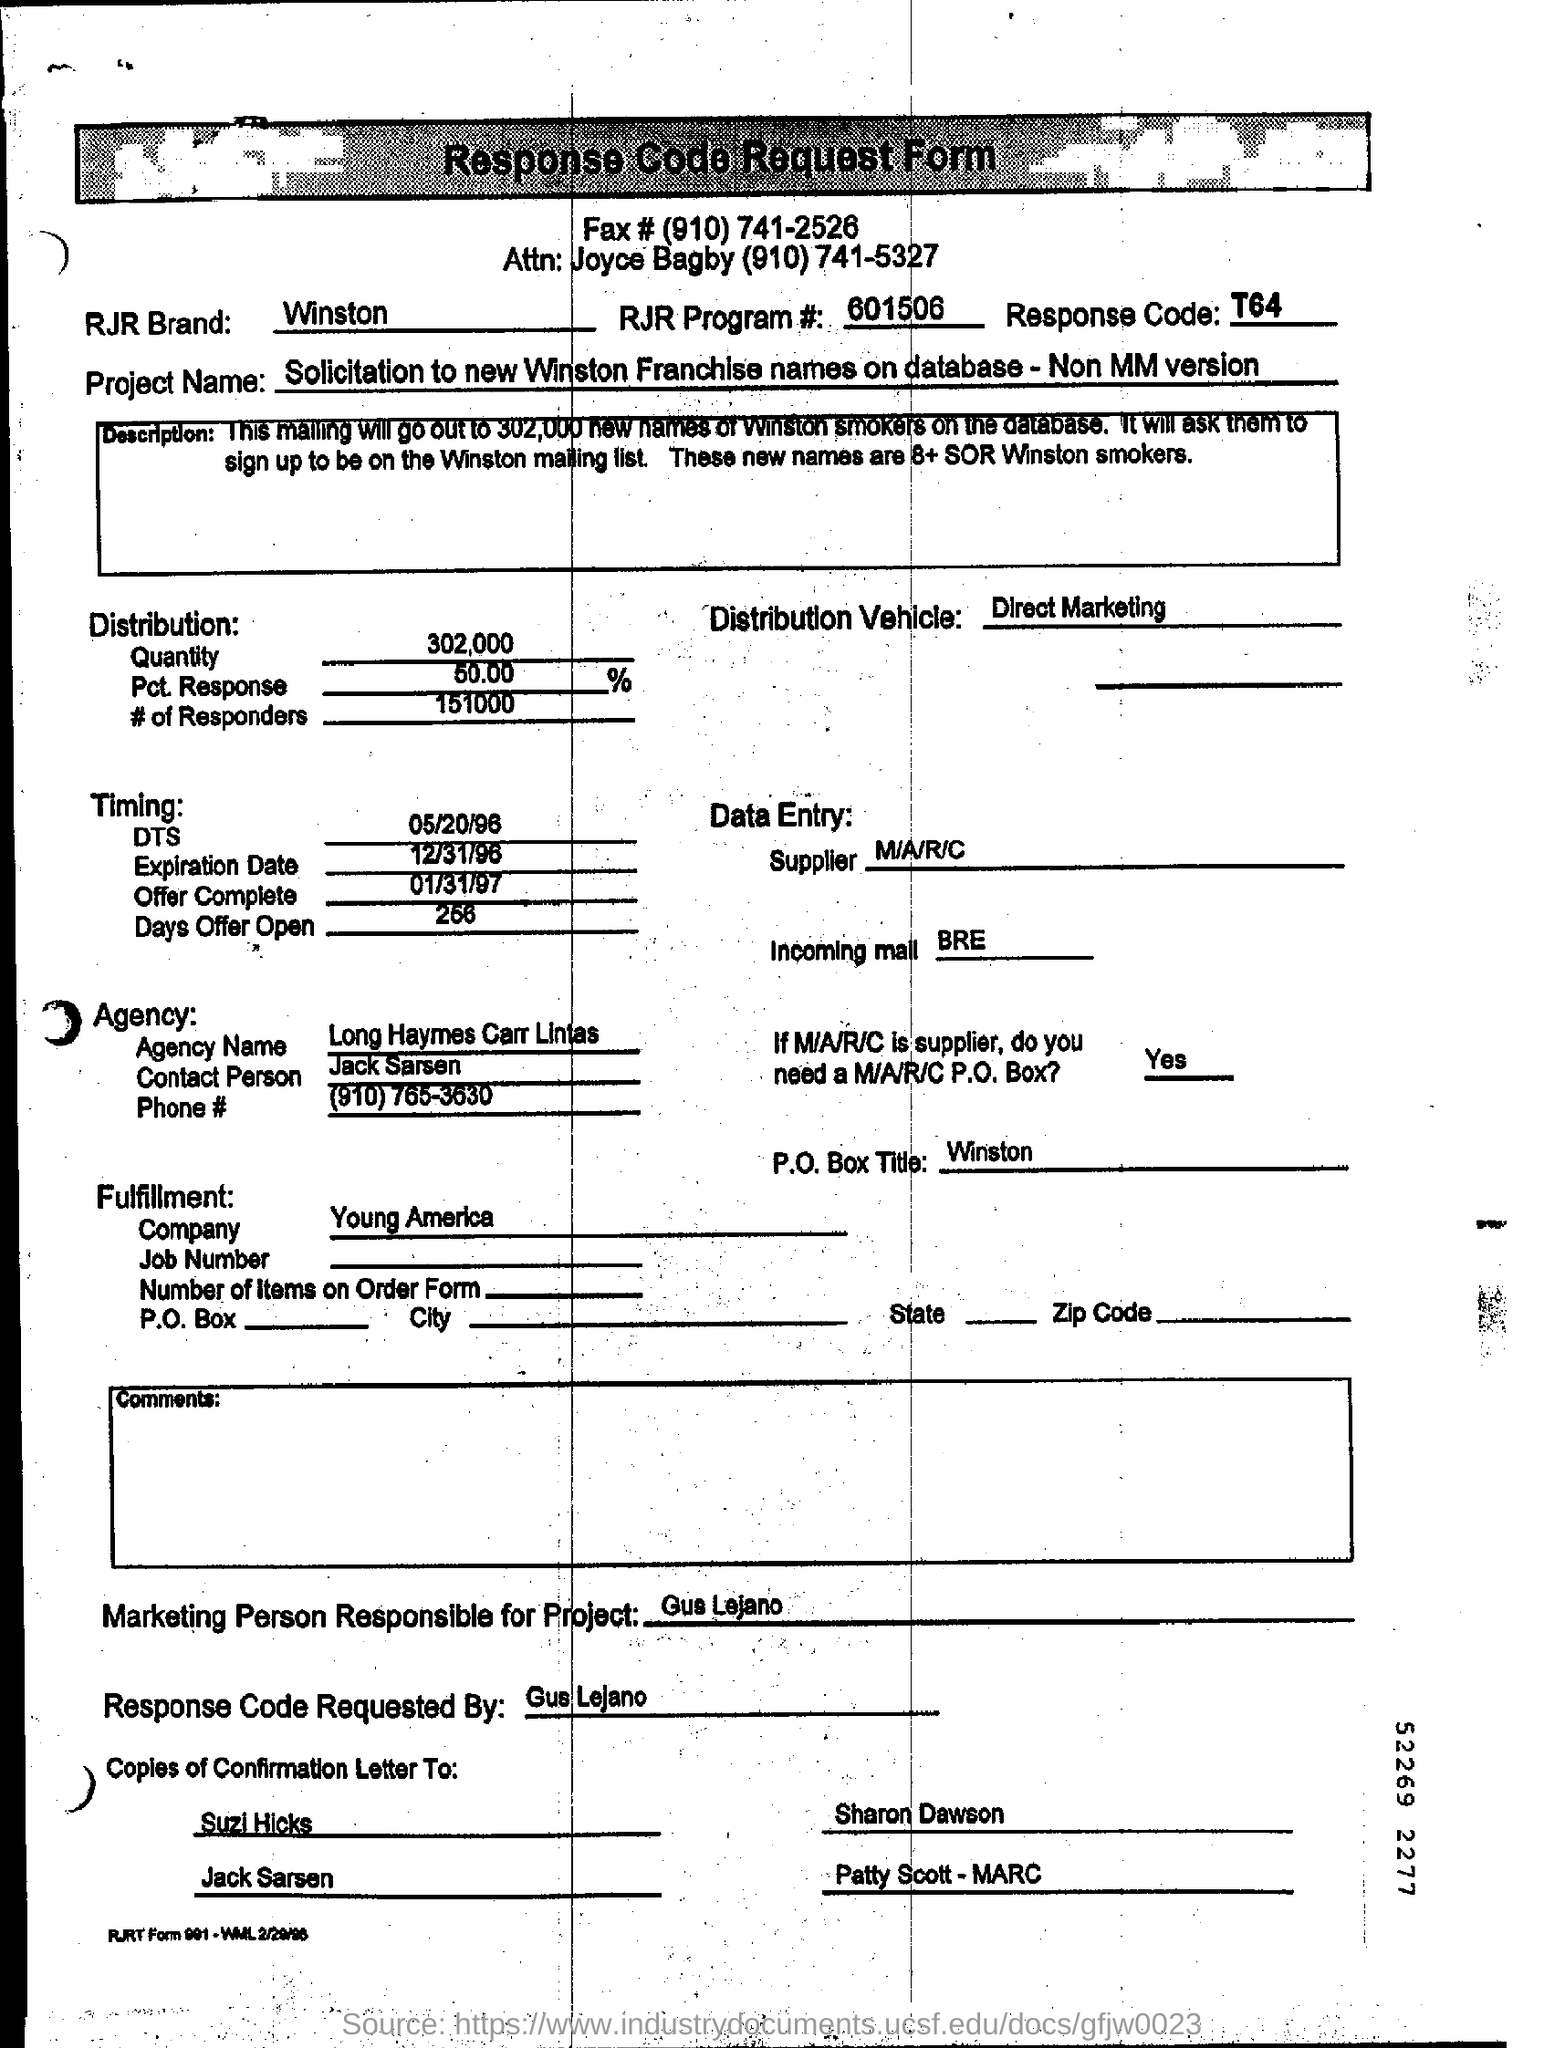What is the quantity given in the  distribution?
Your answer should be very brief. 302,000. Who is  the contact person of the agency?
Make the answer very short. Jack Sarsen. 